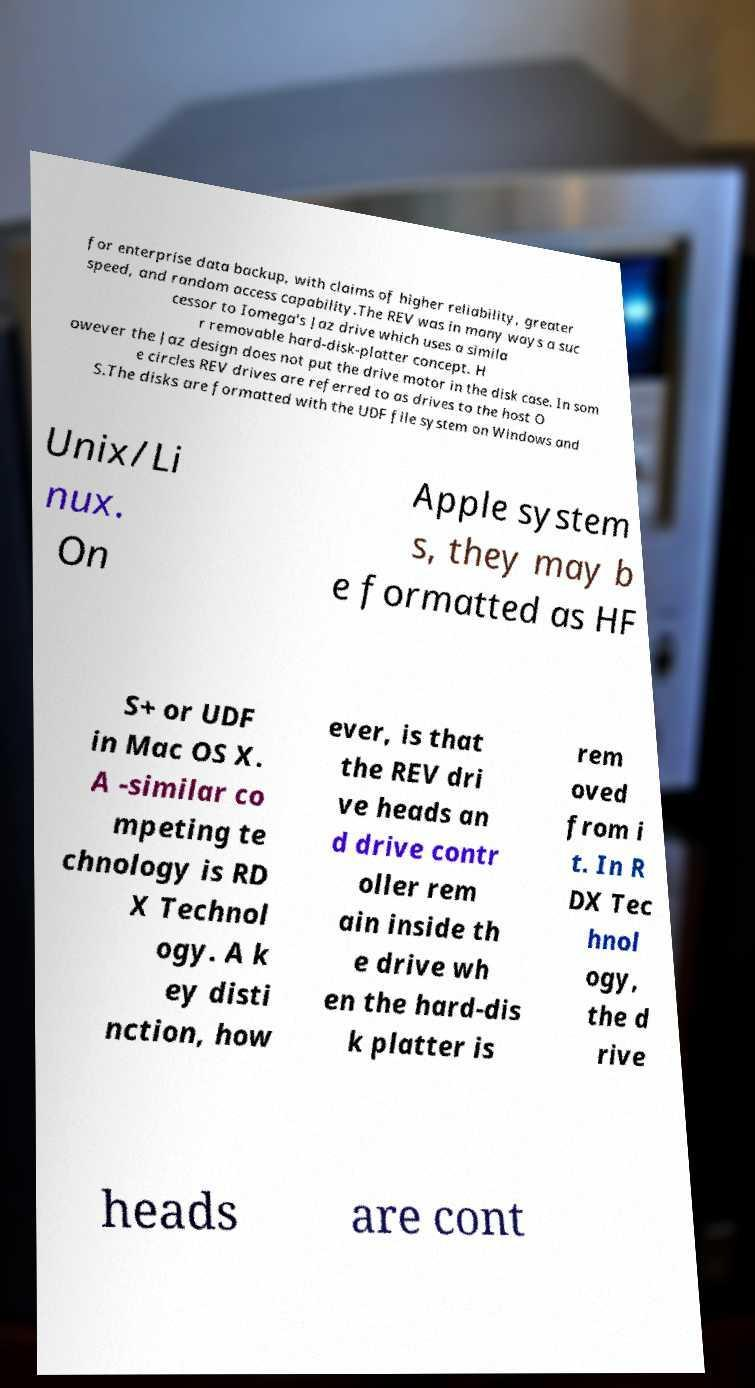Could you assist in decoding the text presented in this image and type it out clearly? for enterprise data backup, with claims of higher reliability, greater speed, and random access capability.The REV was in many ways a suc cessor to Iomega's Jaz drive which uses a simila r removable hard-disk-platter concept. H owever the Jaz design does not put the drive motor in the disk case. In som e circles REV drives are referred to as drives to the host O S.The disks are formatted with the UDF file system on Windows and Unix/Li nux. On Apple system s, they may b e formatted as HF S+ or UDF in Mac OS X. A -similar co mpeting te chnology is RD X Technol ogy. A k ey disti nction, how ever, is that the REV dri ve heads an d drive contr oller rem ain inside th e drive wh en the hard-dis k platter is rem oved from i t. In R DX Tec hnol ogy, the d rive heads are cont 